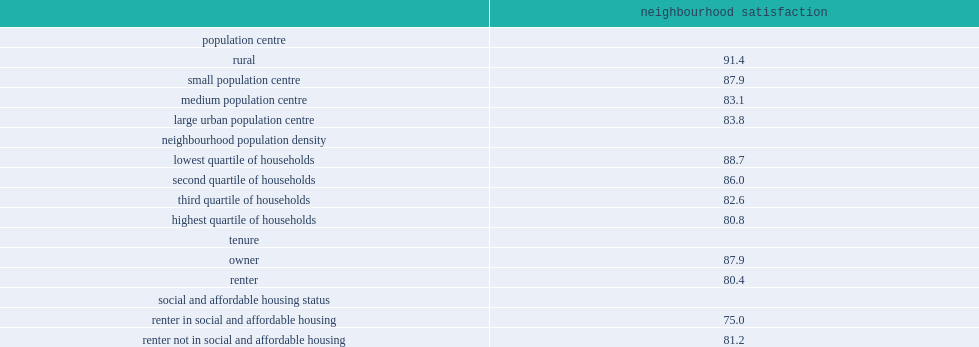How many percent of households living in rural areas were more satisfied with their neighbourhood? 91.4. In general, what the neighbourhood satisfaction rate do owner households have? 87.9. In general, what the neighbourhood satisfaction rate do renter households have? 80.4. Which group are renters in having a lower neighbourhood satisfaction rate? Renter in social and affordable housing. 